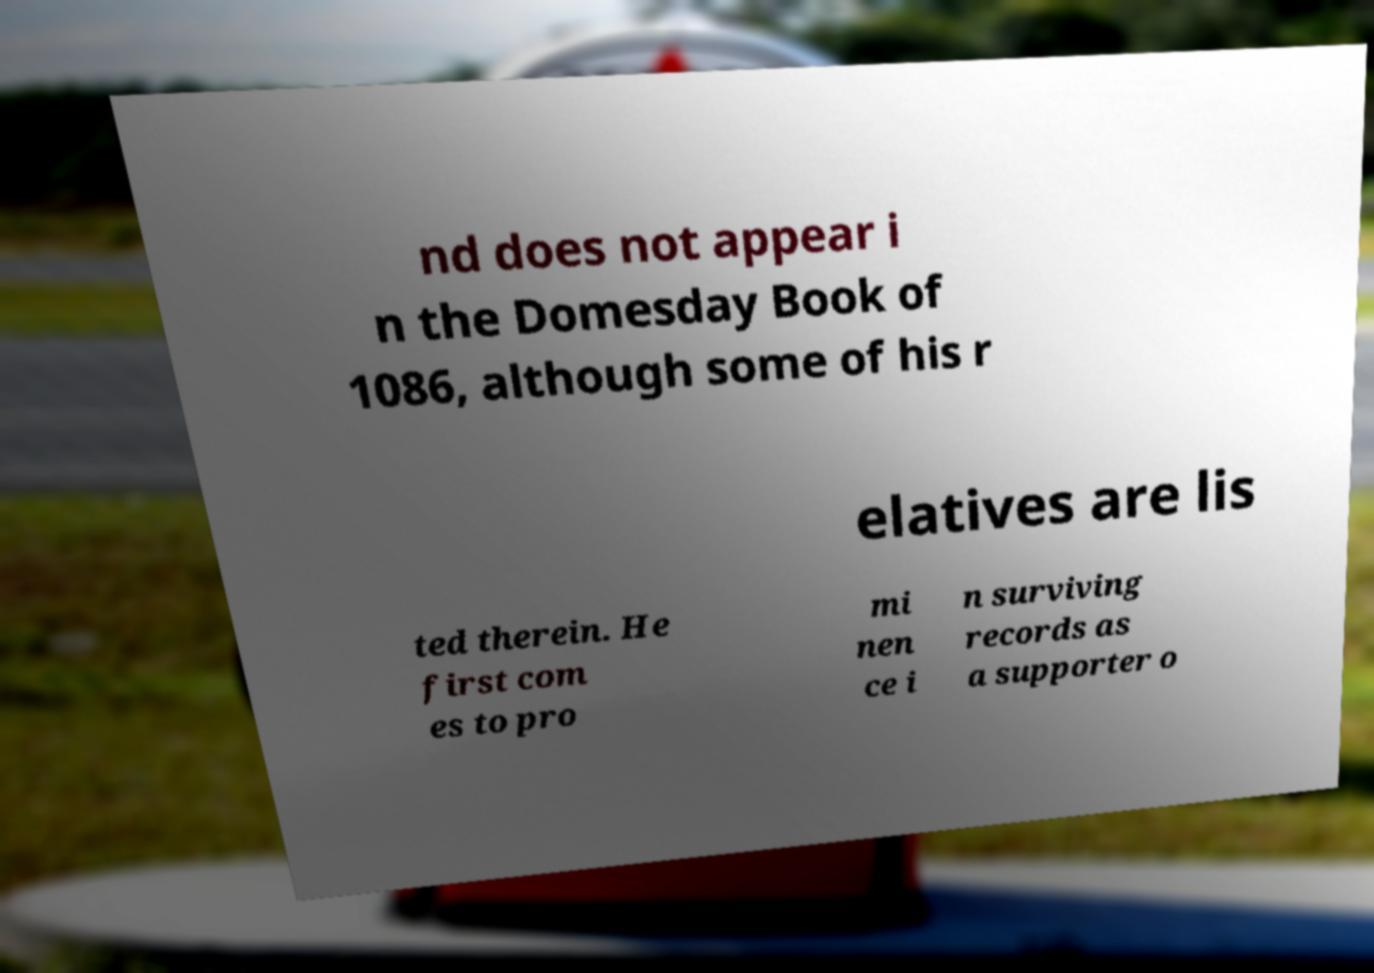There's text embedded in this image that I need extracted. Can you transcribe it verbatim? nd does not appear i n the Domesday Book of 1086, although some of his r elatives are lis ted therein. He first com es to pro mi nen ce i n surviving records as a supporter o 